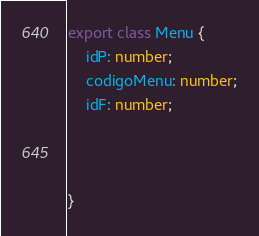<code> <loc_0><loc_0><loc_500><loc_500><_TypeScript_>export class Menu {
    idP: number;
    codigoMenu: number;
    idF: number;
    


}</code> 